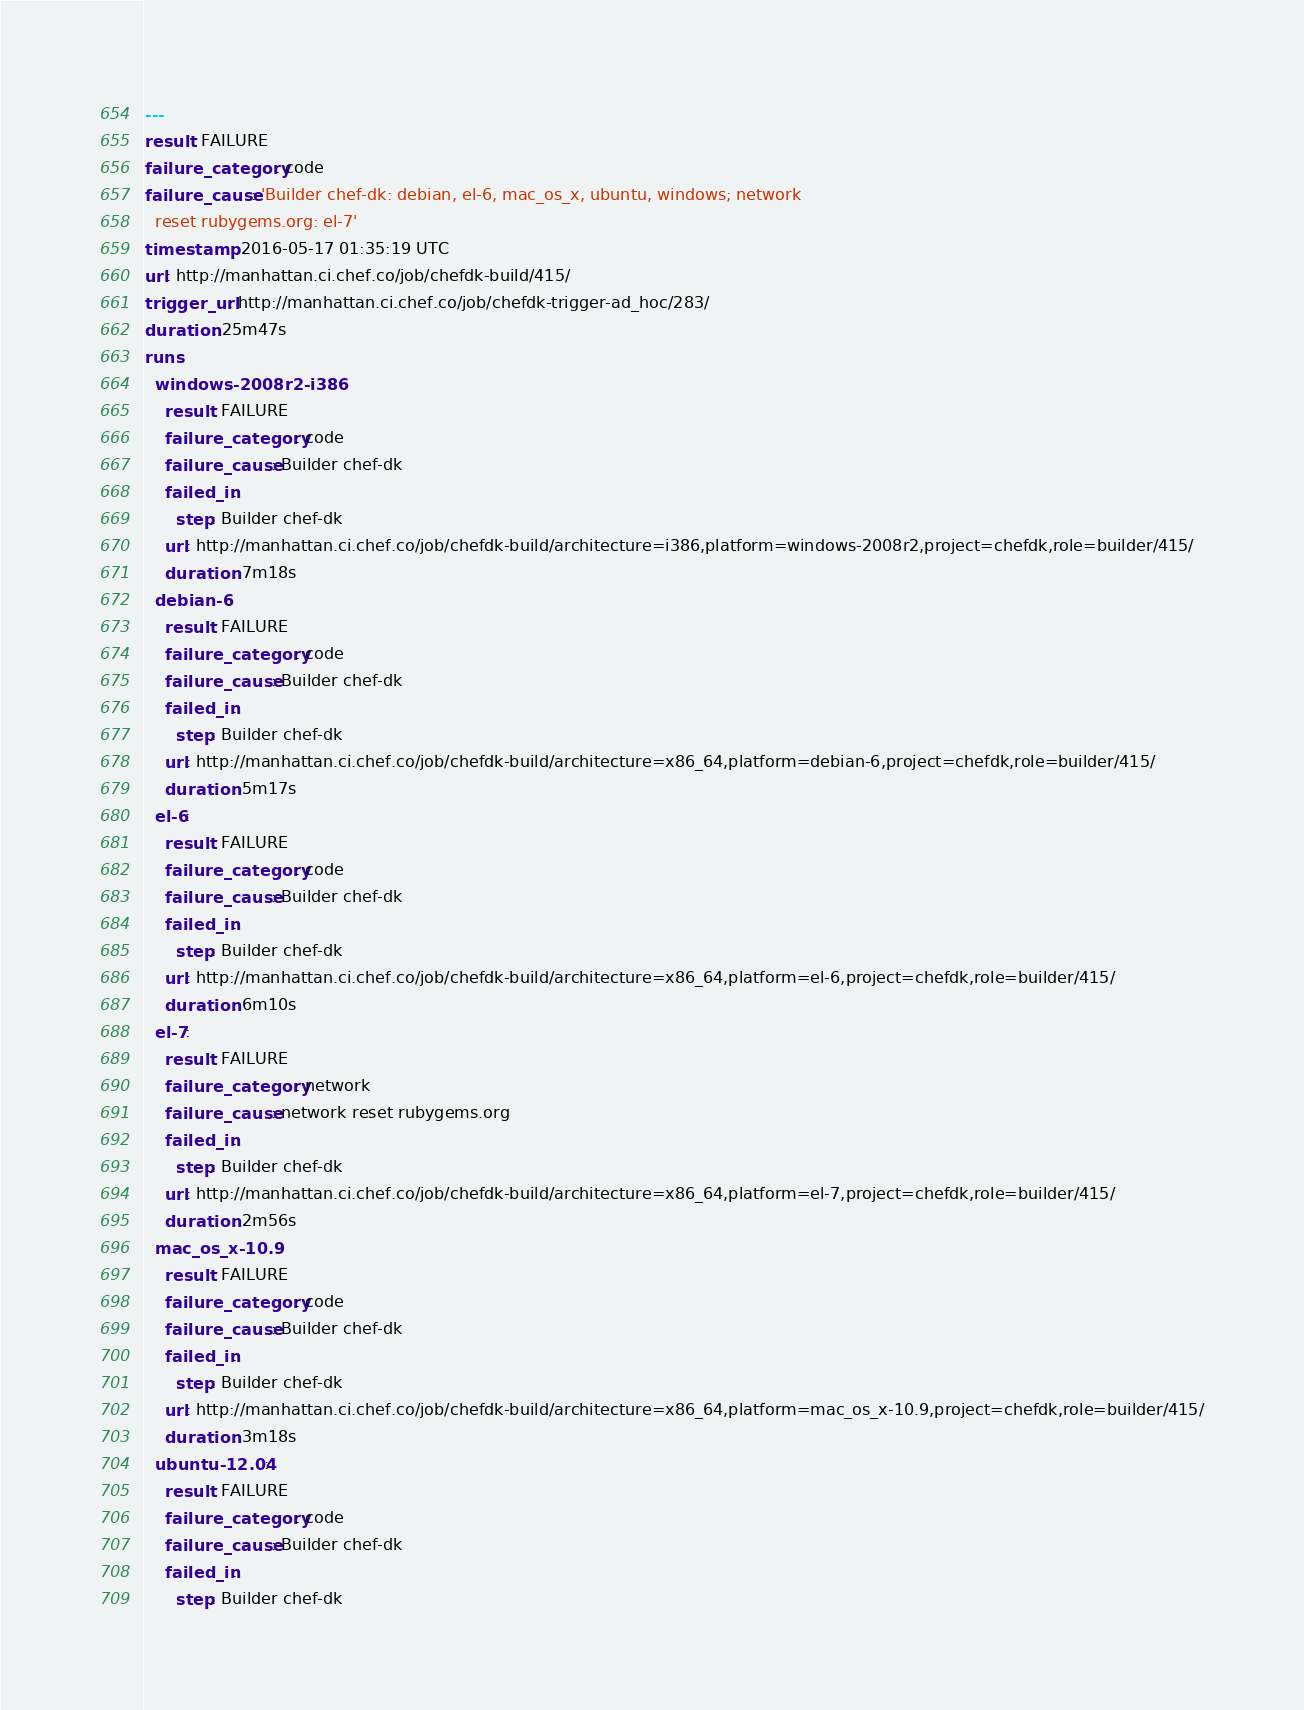Convert code to text. <code><loc_0><loc_0><loc_500><loc_500><_YAML_>---
result: FAILURE
failure_category: code
failure_cause: 'Builder chef-dk: debian, el-6, mac_os_x, ubuntu, windows; network
  reset rubygems.org: el-7'
timestamp: 2016-05-17 01:35:19 UTC
url: http://manhattan.ci.chef.co/job/chefdk-build/415/
trigger_url: http://manhattan.ci.chef.co/job/chefdk-trigger-ad_hoc/283/
duration: 25m47s
runs:
  windows-2008r2-i386:
    result: FAILURE
    failure_category: code
    failure_cause: Builder chef-dk
    failed_in:
      step: Builder chef-dk
    url: http://manhattan.ci.chef.co/job/chefdk-build/architecture=i386,platform=windows-2008r2,project=chefdk,role=builder/415/
    duration: 7m18s
  debian-6:
    result: FAILURE
    failure_category: code
    failure_cause: Builder chef-dk
    failed_in:
      step: Builder chef-dk
    url: http://manhattan.ci.chef.co/job/chefdk-build/architecture=x86_64,platform=debian-6,project=chefdk,role=builder/415/
    duration: 5m17s
  el-6:
    result: FAILURE
    failure_category: code
    failure_cause: Builder chef-dk
    failed_in:
      step: Builder chef-dk
    url: http://manhattan.ci.chef.co/job/chefdk-build/architecture=x86_64,platform=el-6,project=chefdk,role=builder/415/
    duration: 6m10s
  el-7:
    result: FAILURE
    failure_category: network
    failure_cause: network reset rubygems.org
    failed_in:
      step: Builder chef-dk
    url: http://manhattan.ci.chef.co/job/chefdk-build/architecture=x86_64,platform=el-7,project=chefdk,role=builder/415/
    duration: 2m56s
  mac_os_x-10.9:
    result: FAILURE
    failure_category: code
    failure_cause: Builder chef-dk
    failed_in:
      step: Builder chef-dk
    url: http://manhattan.ci.chef.co/job/chefdk-build/architecture=x86_64,platform=mac_os_x-10.9,project=chefdk,role=builder/415/
    duration: 3m18s
  ubuntu-12.04:
    result: FAILURE
    failure_category: code
    failure_cause: Builder chef-dk
    failed_in:
      step: Builder chef-dk</code> 